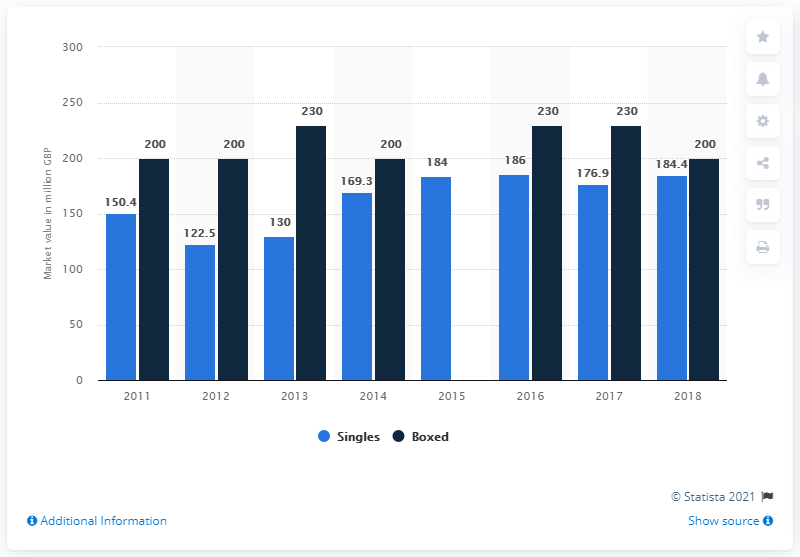Mention a couple of crucial points in this snapshot. In 2018, the estimated value of boxed Christmas cards was approximately 200. The market for single Christmas cards was valued at approximately 184 million dollars in 2018. The estimated value of Christmas greeting cards in the UK was in 2011. 